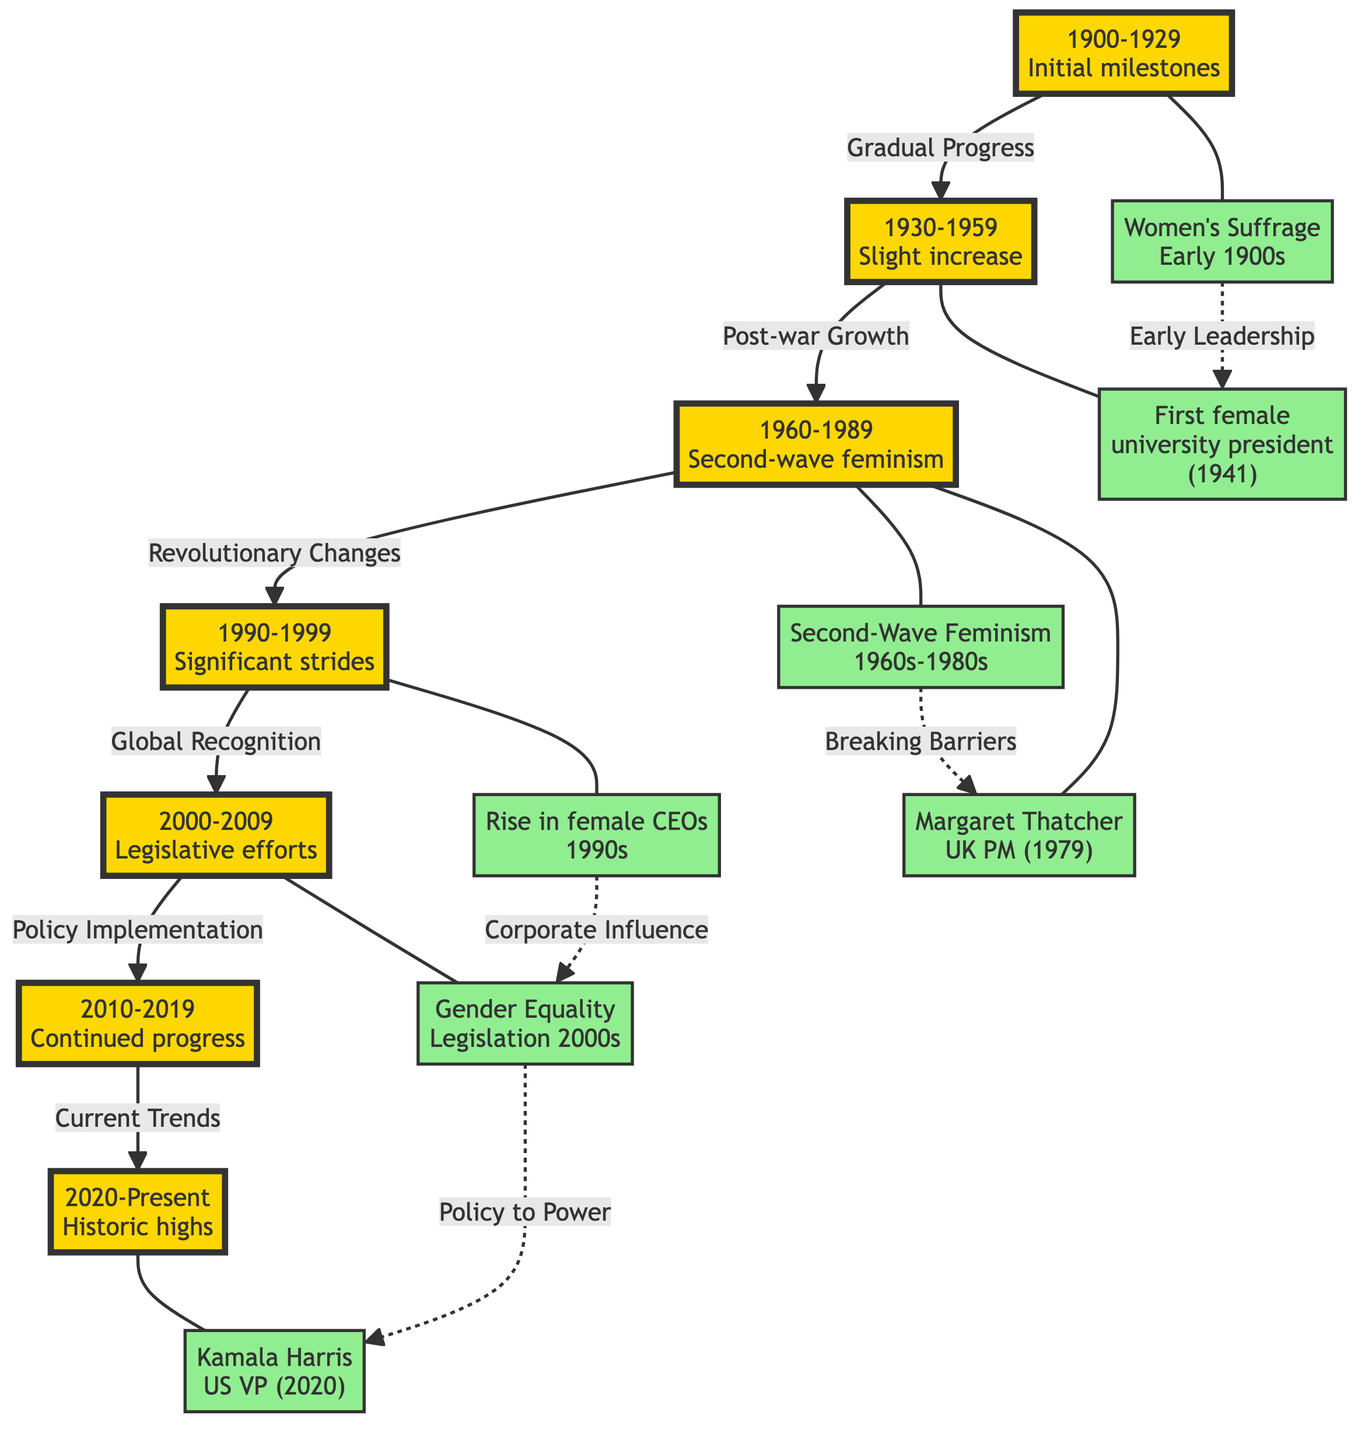What is the first milestone shown in the diagram? The first milestone in the diagram is "Women's Suffrage<br/>Early 1900s." This can be identified as it is directly linked to the "1900-1929" era node.
Answer: Women's Suffrage Which decade is associated with the rise of female CEOs? The rise in female CEOs is associated with the "1990s" decade, as indicated by the direct connection to the milestone labeled "Rise in female CEOs<br/>1990s."
Answer: 1990s What milestone is shown in the 1960s? In the 1960s, there are two milestones: "Second-Wave Feminism<br/>1960s-1980s" and "Margaret Thatcher<br/>UK PM (1979)." This indicates significant events related to women's leadership during that era.
Answer: Second-Wave Feminism, Margaret Thatcher How many eras are depicted in the diagram? The diagram clearly shows seven distinct eras, each marked by specific milestones occurring in different decades from the 1900s to the 2020s. These eras are visually separated and labeled.
Answer: 7 What links the milestone "Kamala Harris<br/>US VP (2020)" to the previous one? "Kamala Harris<br/>US VP (2020)" is linked to the "Gender Equality<br/>Legislation 2000s" milestone through the relationship labeled "Policy to Power," indicating a progression from legislation to holding high political office.
Answer: Policy to Power What type of relationship exists between the "Women's Suffrage" milestone and the "First female university president" milestone? The relationship between "Women's Suffrage" and "First female university president" is shown as a dashed line labeled "Early Leadership," suggesting that early women's suffrage contributed to later leadership roles in education.
Answer: Early Leadership Which decade shows continued progress after legislative efforts? After the legislative efforts in the 2000s, the diagram shows the decade of the "2010s," which is characterized by continued progress towards gender equality in leadership roles.
Answer: 2010s What is a notable characteristic of the "2020-Present" era in the diagram? The characteristic of the "2020-Present" era is noted as being a time of "Historic highs," indicating that this period marks a significant increase in women's representation in leadership positions globally.
Answer: Historic highs 